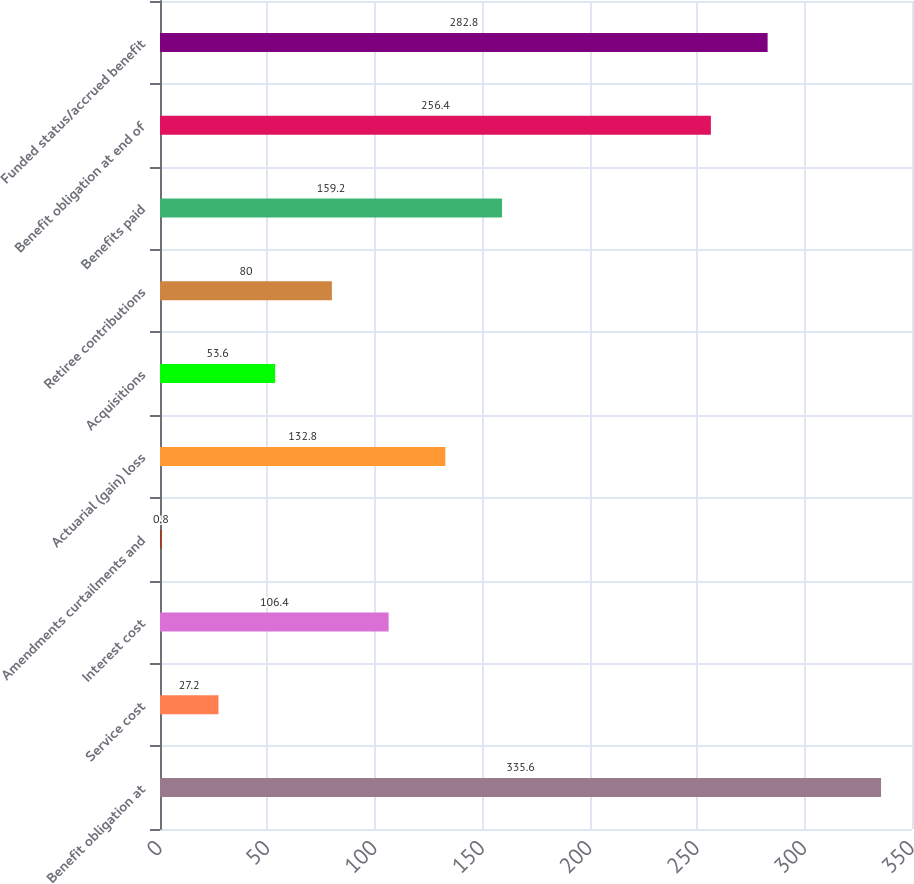<chart> <loc_0><loc_0><loc_500><loc_500><bar_chart><fcel>Benefit obligation at<fcel>Service cost<fcel>Interest cost<fcel>Amendments curtailments and<fcel>Actuarial (gain) loss<fcel>Acquisitions<fcel>Retiree contributions<fcel>Benefits paid<fcel>Benefit obligation at end of<fcel>Funded status/accrued benefit<nl><fcel>335.6<fcel>27.2<fcel>106.4<fcel>0.8<fcel>132.8<fcel>53.6<fcel>80<fcel>159.2<fcel>256.4<fcel>282.8<nl></chart> 